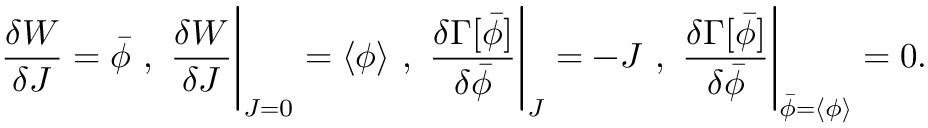Convert formula to latex. <formula><loc_0><loc_0><loc_500><loc_500>{ \frac { \delta W } { \delta J } } = { \bar { \phi } } , { \frac { \delta W } { \delta J } } { \Big | } _ { J = 0 } = \langle \phi \rangle , { \frac { \delta \Gamma [ { \bar { \phi } } ] } { \delta { \bar { \phi } } } } { \Big | } _ { J } = - J , { \frac { \delta \Gamma [ { \bar { \phi } } ] } { \delta { \bar { \phi } } } } { \Big | } _ { { \bar { \phi } } = \langle \phi \rangle } = 0 .</formula> 